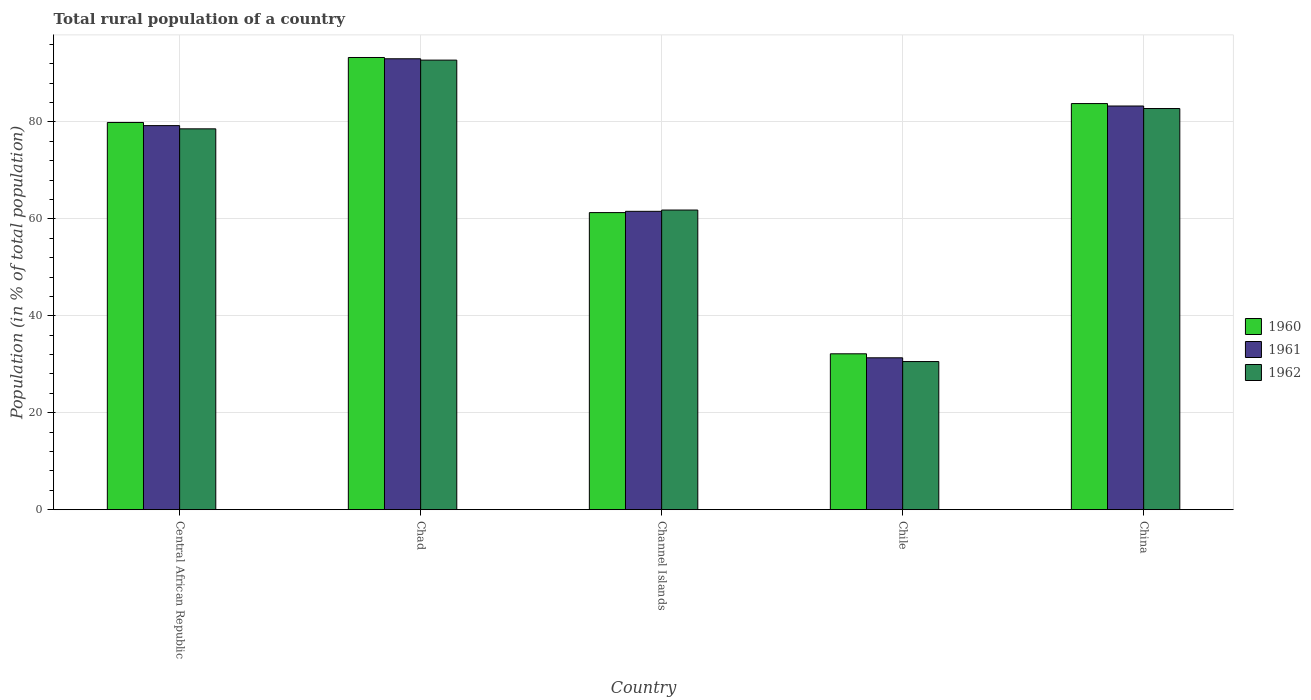Are the number of bars per tick equal to the number of legend labels?
Offer a very short reply. Yes. How many bars are there on the 5th tick from the left?
Keep it short and to the point. 3. How many bars are there on the 5th tick from the right?
Ensure brevity in your answer.  3. What is the label of the 5th group of bars from the left?
Offer a terse response. China. What is the rural population in 1960 in Central African Republic?
Offer a terse response. 79.9. Across all countries, what is the maximum rural population in 1960?
Offer a terse response. 93.31. Across all countries, what is the minimum rural population in 1962?
Provide a short and direct response. 30.57. In which country was the rural population in 1961 maximum?
Your answer should be very brief. Chad. In which country was the rural population in 1962 minimum?
Your answer should be compact. Chile. What is the total rural population in 1961 in the graph?
Provide a succinct answer. 348.48. What is the difference between the rural population in 1960 in Channel Islands and that in Chile?
Offer a terse response. 29.14. What is the difference between the rural population in 1962 in Channel Islands and the rural population in 1961 in Central African Republic?
Your answer should be very brief. -17.42. What is the average rural population in 1962 per country?
Make the answer very short. 69.3. What is the difference between the rural population of/in 1960 and rural population of/in 1962 in Central African Republic?
Ensure brevity in your answer.  1.32. What is the ratio of the rural population in 1960 in Chile to that in China?
Keep it short and to the point. 0.38. Is the difference between the rural population in 1960 in Central African Republic and Channel Islands greater than the difference between the rural population in 1962 in Central African Republic and Channel Islands?
Provide a succinct answer. Yes. What is the difference between the highest and the second highest rural population in 1960?
Ensure brevity in your answer.  -9.51. What is the difference between the highest and the lowest rural population in 1962?
Your response must be concise. 62.2. Is the sum of the rural population in 1961 in Central African Republic and Channel Islands greater than the maximum rural population in 1962 across all countries?
Offer a very short reply. Yes. What does the 3rd bar from the left in Chile represents?
Your answer should be compact. 1962. Is it the case that in every country, the sum of the rural population in 1960 and rural population in 1962 is greater than the rural population in 1961?
Provide a succinct answer. Yes. How many bars are there?
Ensure brevity in your answer.  15. Are all the bars in the graph horizontal?
Offer a very short reply. No. Where does the legend appear in the graph?
Your response must be concise. Center right. How many legend labels are there?
Provide a short and direct response. 3. What is the title of the graph?
Ensure brevity in your answer.  Total rural population of a country. Does "1960" appear as one of the legend labels in the graph?
Keep it short and to the point. Yes. What is the label or title of the Y-axis?
Your response must be concise. Population (in % of total population). What is the Population (in % of total population) of 1960 in Central African Republic?
Keep it short and to the point. 79.9. What is the Population (in % of total population) of 1961 in Central African Republic?
Provide a short and direct response. 79.25. What is the Population (in % of total population) in 1962 in Central African Republic?
Provide a succinct answer. 78.58. What is the Population (in % of total population) in 1960 in Chad?
Offer a terse response. 93.31. What is the Population (in % of total population) of 1961 in Chad?
Provide a succinct answer. 93.04. What is the Population (in % of total population) in 1962 in Chad?
Offer a terse response. 92.76. What is the Population (in % of total population) of 1960 in Channel Islands?
Your answer should be compact. 61.3. What is the Population (in % of total population) of 1961 in Channel Islands?
Ensure brevity in your answer.  61.56. What is the Population (in % of total population) in 1962 in Channel Islands?
Ensure brevity in your answer.  61.83. What is the Population (in % of total population) of 1960 in Chile?
Your answer should be compact. 32.16. What is the Population (in % of total population) of 1961 in Chile?
Your response must be concise. 31.34. What is the Population (in % of total population) of 1962 in Chile?
Provide a short and direct response. 30.57. What is the Population (in % of total population) of 1960 in China?
Provide a succinct answer. 83.8. What is the Population (in % of total population) in 1961 in China?
Provide a succinct answer. 83.29. What is the Population (in % of total population) in 1962 in China?
Your answer should be very brief. 82.77. Across all countries, what is the maximum Population (in % of total population) of 1960?
Offer a very short reply. 93.31. Across all countries, what is the maximum Population (in % of total population) of 1961?
Make the answer very short. 93.04. Across all countries, what is the maximum Population (in % of total population) of 1962?
Keep it short and to the point. 92.76. Across all countries, what is the minimum Population (in % of total population) of 1960?
Provide a short and direct response. 32.16. Across all countries, what is the minimum Population (in % of total population) of 1961?
Your answer should be very brief. 31.34. Across all countries, what is the minimum Population (in % of total population) in 1962?
Your answer should be very brief. 30.57. What is the total Population (in % of total population) in 1960 in the graph?
Provide a succinct answer. 350.47. What is the total Population (in % of total population) of 1961 in the graph?
Give a very brief answer. 348.48. What is the total Population (in % of total population) in 1962 in the graph?
Ensure brevity in your answer.  346.51. What is the difference between the Population (in % of total population) of 1960 in Central African Republic and that in Chad?
Your answer should be compact. -13.4. What is the difference between the Population (in % of total population) of 1961 in Central African Republic and that in Chad?
Give a very brief answer. -13.79. What is the difference between the Population (in % of total population) in 1962 in Central African Republic and that in Chad?
Offer a terse response. -14.18. What is the difference between the Population (in % of total population) of 1960 in Central African Republic and that in Channel Islands?
Offer a terse response. 18.6. What is the difference between the Population (in % of total population) in 1961 in Central African Republic and that in Channel Islands?
Your answer should be compact. 17.68. What is the difference between the Population (in % of total population) in 1962 in Central African Republic and that in Channel Islands?
Offer a terse response. 16.75. What is the difference between the Population (in % of total population) in 1960 in Central African Republic and that in Chile?
Provide a succinct answer. 47.74. What is the difference between the Population (in % of total population) of 1961 in Central African Republic and that in Chile?
Your answer should be compact. 47.91. What is the difference between the Population (in % of total population) in 1962 in Central African Republic and that in Chile?
Make the answer very short. 48.02. What is the difference between the Population (in % of total population) in 1960 in Central African Republic and that in China?
Make the answer very short. -3.9. What is the difference between the Population (in % of total population) of 1961 in Central African Republic and that in China?
Your response must be concise. -4.04. What is the difference between the Population (in % of total population) in 1962 in Central African Republic and that in China?
Offer a terse response. -4.19. What is the difference between the Population (in % of total population) in 1960 in Chad and that in Channel Islands?
Your answer should be compact. 32.01. What is the difference between the Population (in % of total population) in 1961 in Chad and that in Channel Islands?
Your answer should be compact. 31.47. What is the difference between the Population (in % of total population) in 1962 in Chad and that in Channel Islands?
Your answer should be very brief. 30.93. What is the difference between the Population (in % of total population) in 1960 in Chad and that in Chile?
Your answer should be very brief. 61.14. What is the difference between the Population (in % of total population) in 1961 in Chad and that in Chile?
Keep it short and to the point. 61.7. What is the difference between the Population (in % of total population) of 1962 in Chad and that in Chile?
Offer a terse response. 62.2. What is the difference between the Population (in % of total population) in 1960 in Chad and that in China?
Make the answer very short. 9.51. What is the difference between the Population (in % of total population) in 1961 in Chad and that in China?
Offer a very short reply. 9.75. What is the difference between the Population (in % of total population) in 1962 in Chad and that in China?
Your answer should be very brief. 9.99. What is the difference between the Population (in % of total population) of 1960 in Channel Islands and that in Chile?
Keep it short and to the point. 29.14. What is the difference between the Population (in % of total population) in 1961 in Channel Islands and that in Chile?
Ensure brevity in your answer.  30.22. What is the difference between the Population (in % of total population) in 1962 in Channel Islands and that in Chile?
Make the answer very short. 31.26. What is the difference between the Population (in % of total population) in 1960 in Channel Islands and that in China?
Keep it short and to the point. -22.5. What is the difference between the Population (in % of total population) of 1961 in Channel Islands and that in China?
Ensure brevity in your answer.  -21.73. What is the difference between the Population (in % of total population) in 1962 in Channel Islands and that in China?
Your response must be concise. -20.95. What is the difference between the Population (in % of total population) of 1960 in Chile and that in China?
Offer a very short reply. -51.63. What is the difference between the Population (in % of total population) in 1961 in Chile and that in China?
Make the answer very short. -51.95. What is the difference between the Population (in % of total population) of 1962 in Chile and that in China?
Provide a succinct answer. -52.21. What is the difference between the Population (in % of total population) of 1960 in Central African Republic and the Population (in % of total population) of 1961 in Chad?
Provide a short and direct response. -13.14. What is the difference between the Population (in % of total population) in 1960 in Central African Republic and the Population (in % of total population) in 1962 in Chad?
Your answer should be very brief. -12.86. What is the difference between the Population (in % of total population) of 1961 in Central African Republic and the Population (in % of total population) of 1962 in Chad?
Provide a succinct answer. -13.51. What is the difference between the Population (in % of total population) of 1960 in Central African Republic and the Population (in % of total population) of 1961 in Channel Islands?
Offer a very short reply. 18.34. What is the difference between the Population (in % of total population) of 1960 in Central African Republic and the Population (in % of total population) of 1962 in Channel Islands?
Give a very brief answer. 18.07. What is the difference between the Population (in % of total population) of 1961 in Central African Republic and the Population (in % of total population) of 1962 in Channel Islands?
Make the answer very short. 17.42. What is the difference between the Population (in % of total population) in 1960 in Central African Republic and the Population (in % of total population) in 1961 in Chile?
Your answer should be compact. 48.56. What is the difference between the Population (in % of total population) of 1960 in Central African Republic and the Population (in % of total population) of 1962 in Chile?
Your answer should be compact. 49.34. What is the difference between the Population (in % of total population) of 1961 in Central African Republic and the Population (in % of total population) of 1962 in Chile?
Your response must be concise. 48.68. What is the difference between the Population (in % of total population) in 1960 in Central African Republic and the Population (in % of total population) in 1961 in China?
Your response must be concise. -3.39. What is the difference between the Population (in % of total population) of 1960 in Central African Republic and the Population (in % of total population) of 1962 in China?
Your answer should be very brief. -2.87. What is the difference between the Population (in % of total population) in 1961 in Central African Republic and the Population (in % of total population) in 1962 in China?
Your answer should be very brief. -3.52. What is the difference between the Population (in % of total population) in 1960 in Chad and the Population (in % of total population) in 1961 in Channel Islands?
Provide a short and direct response. 31.74. What is the difference between the Population (in % of total population) in 1960 in Chad and the Population (in % of total population) in 1962 in Channel Islands?
Offer a terse response. 31.48. What is the difference between the Population (in % of total population) of 1961 in Chad and the Population (in % of total population) of 1962 in Channel Islands?
Give a very brief answer. 31.21. What is the difference between the Population (in % of total population) in 1960 in Chad and the Population (in % of total population) in 1961 in Chile?
Give a very brief answer. 61.97. What is the difference between the Population (in % of total population) of 1960 in Chad and the Population (in % of total population) of 1962 in Chile?
Your response must be concise. 62.74. What is the difference between the Population (in % of total population) in 1961 in Chad and the Population (in % of total population) in 1962 in Chile?
Provide a short and direct response. 62.47. What is the difference between the Population (in % of total population) of 1960 in Chad and the Population (in % of total population) of 1961 in China?
Offer a very short reply. 10.01. What is the difference between the Population (in % of total population) of 1960 in Chad and the Population (in % of total population) of 1962 in China?
Provide a succinct answer. 10.53. What is the difference between the Population (in % of total population) of 1961 in Chad and the Population (in % of total population) of 1962 in China?
Provide a short and direct response. 10.26. What is the difference between the Population (in % of total population) of 1960 in Channel Islands and the Population (in % of total population) of 1961 in Chile?
Provide a short and direct response. 29.96. What is the difference between the Population (in % of total population) in 1960 in Channel Islands and the Population (in % of total population) in 1962 in Chile?
Make the answer very short. 30.73. What is the difference between the Population (in % of total population) in 1961 in Channel Islands and the Population (in % of total population) in 1962 in Chile?
Ensure brevity in your answer.  31. What is the difference between the Population (in % of total population) in 1960 in Channel Islands and the Population (in % of total population) in 1961 in China?
Your answer should be very brief. -21.99. What is the difference between the Population (in % of total population) of 1960 in Channel Islands and the Population (in % of total population) of 1962 in China?
Make the answer very short. -21.47. What is the difference between the Population (in % of total population) in 1961 in Channel Islands and the Population (in % of total population) in 1962 in China?
Make the answer very short. -21.21. What is the difference between the Population (in % of total population) in 1960 in Chile and the Population (in % of total population) in 1961 in China?
Offer a very short reply. -51.13. What is the difference between the Population (in % of total population) of 1960 in Chile and the Population (in % of total population) of 1962 in China?
Make the answer very short. -50.61. What is the difference between the Population (in % of total population) of 1961 in Chile and the Population (in % of total population) of 1962 in China?
Your answer should be compact. -51.43. What is the average Population (in % of total population) of 1960 per country?
Your answer should be very brief. 70.09. What is the average Population (in % of total population) in 1961 per country?
Your answer should be very brief. 69.7. What is the average Population (in % of total population) of 1962 per country?
Give a very brief answer. 69.3. What is the difference between the Population (in % of total population) in 1960 and Population (in % of total population) in 1961 in Central African Republic?
Offer a very short reply. 0.65. What is the difference between the Population (in % of total population) in 1960 and Population (in % of total population) in 1962 in Central African Republic?
Make the answer very short. 1.32. What is the difference between the Population (in % of total population) of 1961 and Population (in % of total population) of 1962 in Central African Republic?
Your response must be concise. 0.67. What is the difference between the Population (in % of total population) of 1960 and Population (in % of total population) of 1961 in Chad?
Offer a terse response. 0.27. What is the difference between the Population (in % of total population) of 1960 and Population (in % of total population) of 1962 in Chad?
Ensure brevity in your answer.  0.54. What is the difference between the Population (in % of total population) of 1961 and Population (in % of total population) of 1962 in Chad?
Provide a short and direct response. 0.28. What is the difference between the Population (in % of total population) of 1960 and Population (in % of total population) of 1961 in Channel Islands?
Offer a very short reply. -0.26. What is the difference between the Population (in % of total population) of 1960 and Population (in % of total population) of 1962 in Channel Islands?
Your response must be concise. -0.53. What is the difference between the Population (in % of total population) of 1961 and Population (in % of total population) of 1962 in Channel Islands?
Offer a very short reply. -0.26. What is the difference between the Population (in % of total population) in 1960 and Population (in % of total population) in 1961 in Chile?
Give a very brief answer. 0.82. What is the difference between the Population (in % of total population) in 1960 and Population (in % of total population) in 1962 in Chile?
Ensure brevity in your answer.  1.6. What is the difference between the Population (in % of total population) in 1961 and Population (in % of total population) in 1962 in Chile?
Keep it short and to the point. 0.78. What is the difference between the Population (in % of total population) of 1960 and Population (in % of total population) of 1961 in China?
Your answer should be very brief. 0.51. What is the difference between the Population (in % of total population) of 1960 and Population (in % of total population) of 1962 in China?
Offer a terse response. 1.02. What is the difference between the Population (in % of total population) in 1961 and Population (in % of total population) in 1962 in China?
Your answer should be compact. 0.52. What is the ratio of the Population (in % of total population) of 1960 in Central African Republic to that in Chad?
Offer a very short reply. 0.86. What is the ratio of the Population (in % of total population) of 1961 in Central African Republic to that in Chad?
Ensure brevity in your answer.  0.85. What is the ratio of the Population (in % of total population) in 1962 in Central African Republic to that in Chad?
Your answer should be compact. 0.85. What is the ratio of the Population (in % of total population) in 1960 in Central African Republic to that in Channel Islands?
Keep it short and to the point. 1.3. What is the ratio of the Population (in % of total population) in 1961 in Central African Republic to that in Channel Islands?
Ensure brevity in your answer.  1.29. What is the ratio of the Population (in % of total population) of 1962 in Central African Republic to that in Channel Islands?
Keep it short and to the point. 1.27. What is the ratio of the Population (in % of total population) of 1960 in Central African Republic to that in Chile?
Provide a short and direct response. 2.48. What is the ratio of the Population (in % of total population) of 1961 in Central African Republic to that in Chile?
Make the answer very short. 2.53. What is the ratio of the Population (in % of total population) in 1962 in Central African Republic to that in Chile?
Provide a short and direct response. 2.57. What is the ratio of the Population (in % of total population) of 1960 in Central African Republic to that in China?
Give a very brief answer. 0.95. What is the ratio of the Population (in % of total population) in 1961 in Central African Republic to that in China?
Your answer should be compact. 0.95. What is the ratio of the Population (in % of total population) of 1962 in Central African Republic to that in China?
Provide a succinct answer. 0.95. What is the ratio of the Population (in % of total population) in 1960 in Chad to that in Channel Islands?
Offer a terse response. 1.52. What is the ratio of the Population (in % of total population) of 1961 in Chad to that in Channel Islands?
Give a very brief answer. 1.51. What is the ratio of the Population (in % of total population) of 1962 in Chad to that in Channel Islands?
Keep it short and to the point. 1.5. What is the ratio of the Population (in % of total population) in 1960 in Chad to that in Chile?
Keep it short and to the point. 2.9. What is the ratio of the Population (in % of total population) of 1961 in Chad to that in Chile?
Make the answer very short. 2.97. What is the ratio of the Population (in % of total population) in 1962 in Chad to that in Chile?
Your response must be concise. 3.03. What is the ratio of the Population (in % of total population) in 1960 in Chad to that in China?
Keep it short and to the point. 1.11. What is the ratio of the Population (in % of total population) of 1961 in Chad to that in China?
Ensure brevity in your answer.  1.12. What is the ratio of the Population (in % of total population) in 1962 in Chad to that in China?
Offer a terse response. 1.12. What is the ratio of the Population (in % of total population) in 1960 in Channel Islands to that in Chile?
Your response must be concise. 1.91. What is the ratio of the Population (in % of total population) of 1961 in Channel Islands to that in Chile?
Make the answer very short. 1.96. What is the ratio of the Population (in % of total population) in 1962 in Channel Islands to that in Chile?
Ensure brevity in your answer.  2.02. What is the ratio of the Population (in % of total population) of 1960 in Channel Islands to that in China?
Your answer should be very brief. 0.73. What is the ratio of the Population (in % of total population) in 1961 in Channel Islands to that in China?
Offer a very short reply. 0.74. What is the ratio of the Population (in % of total population) in 1962 in Channel Islands to that in China?
Keep it short and to the point. 0.75. What is the ratio of the Population (in % of total population) of 1960 in Chile to that in China?
Offer a very short reply. 0.38. What is the ratio of the Population (in % of total population) in 1961 in Chile to that in China?
Keep it short and to the point. 0.38. What is the ratio of the Population (in % of total population) in 1962 in Chile to that in China?
Ensure brevity in your answer.  0.37. What is the difference between the highest and the second highest Population (in % of total population) in 1960?
Offer a terse response. 9.51. What is the difference between the highest and the second highest Population (in % of total population) of 1961?
Your answer should be very brief. 9.75. What is the difference between the highest and the second highest Population (in % of total population) in 1962?
Keep it short and to the point. 9.99. What is the difference between the highest and the lowest Population (in % of total population) in 1960?
Offer a terse response. 61.14. What is the difference between the highest and the lowest Population (in % of total population) of 1961?
Provide a short and direct response. 61.7. What is the difference between the highest and the lowest Population (in % of total population) in 1962?
Your answer should be very brief. 62.2. 